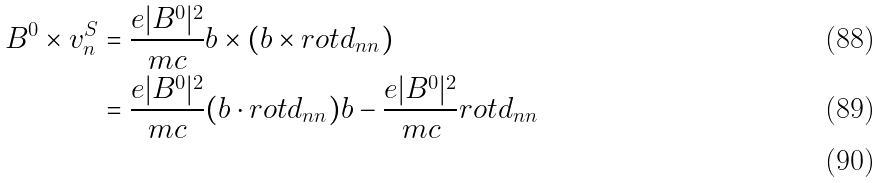<formula> <loc_0><loc_0><loc_500><loc_500>B ^ { 0 } \times { v ^ { S } _ { n } } & = \frac { e | B ^ { 0 } | ^ { 2 } } { m c } { b } \times ( { b } \times { r o t } { d _ { n n } } ) \\ & = \frac { e | B ^ { 0 } | ^ { 2 } } { m c } ( { b } \cdot { r o t } { d _ { n n } } ) { b } - \frac { e | B ^ { 0 } | ^ { 2 } } { m c } { r o t } { d _ { n n } } \\</formula> 